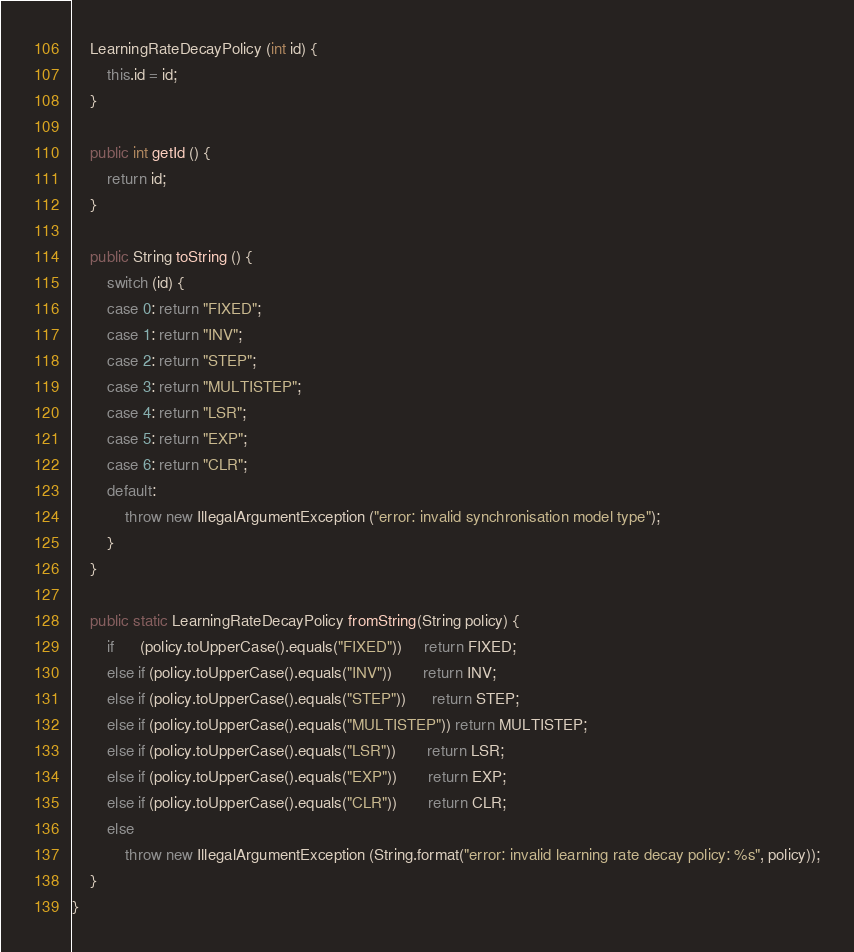Convert code to text. <code><loc_0><loc_0><loc_500><loc_500><_Java_>	LearningRateDecayPolicy (int id) {
		this.id = id;
	}
	
	public int getId () {
		return id;
	}
	
	public String toString () {
		switch (id) {
		case 0: return "FIXED";
		case 1: return "INV";
		case 2: return "STEP";
		case 3: return "MULTISTEP";
		case 4: return "LSR";
		case 5: return "EXP";
		case 6: return "CLR";
		default:
			throw new IllegalArgumentException ("error: invalid synchronisation model type");
		}
	}

	public static LearningRateDecayPolicy fromString(String policy) {
		if      (policy.toUpperCase().equals("FIXED"))     return FIXED;
		else if (policy.toUpperCase().equals("INV"))       return INV;
		else if (policy.toUpperCase().equals("STEP"))      return STEP;
		else if (policy.toUpperCase().equals("MULTISTEP")) return MULTISTEP;
		else if (policy.toUpperCase().equals("LSR"))       return LSR;
		else if (policy.toUpperCase().equals("EXP"))       return EXP;
		else if (policy.toUpperCase().equals("CLR"))       return CLR;
		else
			throw new IllegalArgumentException (String.format("error: invalid learning rate decay policy: %s", policy));
	}
}
</code> 